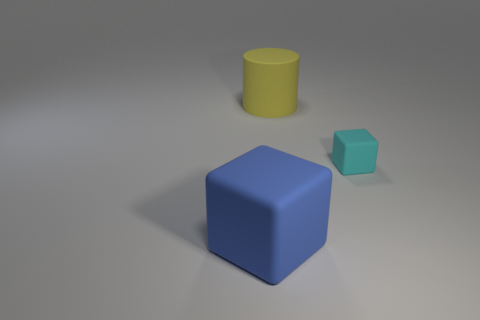Add 3 big gray metal cubes. How many objects exist? 6 Subtract all cylinders. How many objects are left? 2 Subtract all large red matte cylinders. Subtract all tiny rubber things. How many objects are left? 2 Add 2 large yellow cylinders. How many large yellow cylinders are left? 3 Add 1 blue objects. How many blue objects exist? 2 Subtract 0 gray cylinders. How many objects are left? 3 